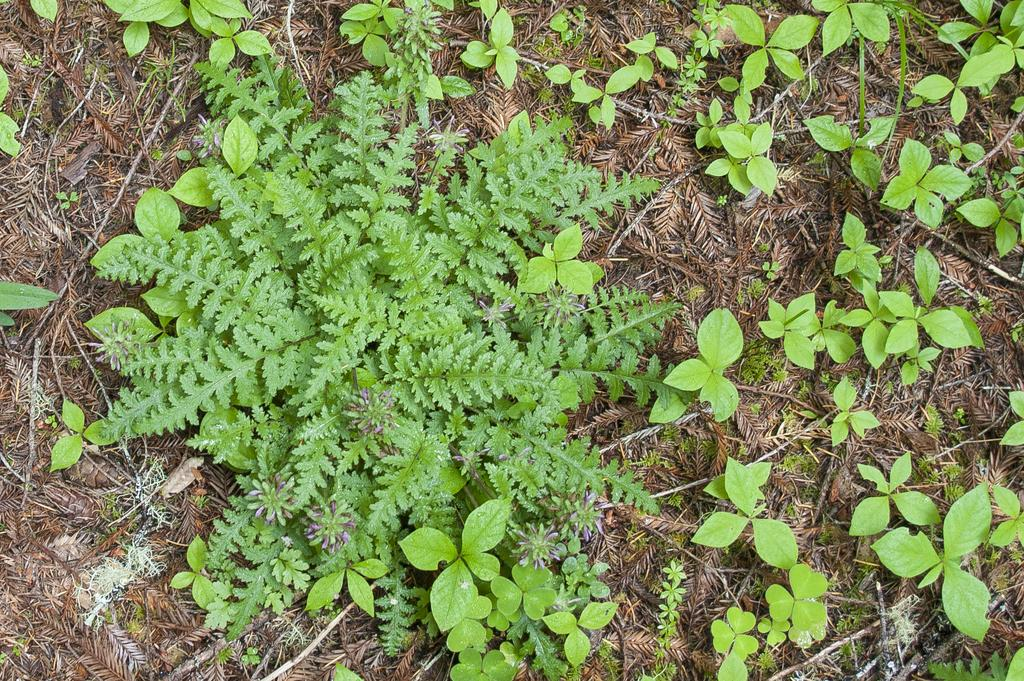What type of living organisms can be seen in the image? Plants can be seen in the image. What else is present on the ground in the image? There are twigs on the ground in the image. What type of religious mass is being held in the image? There is no indication of a religious mass or any religious context in the image; it features plants and twigs on the ground. 